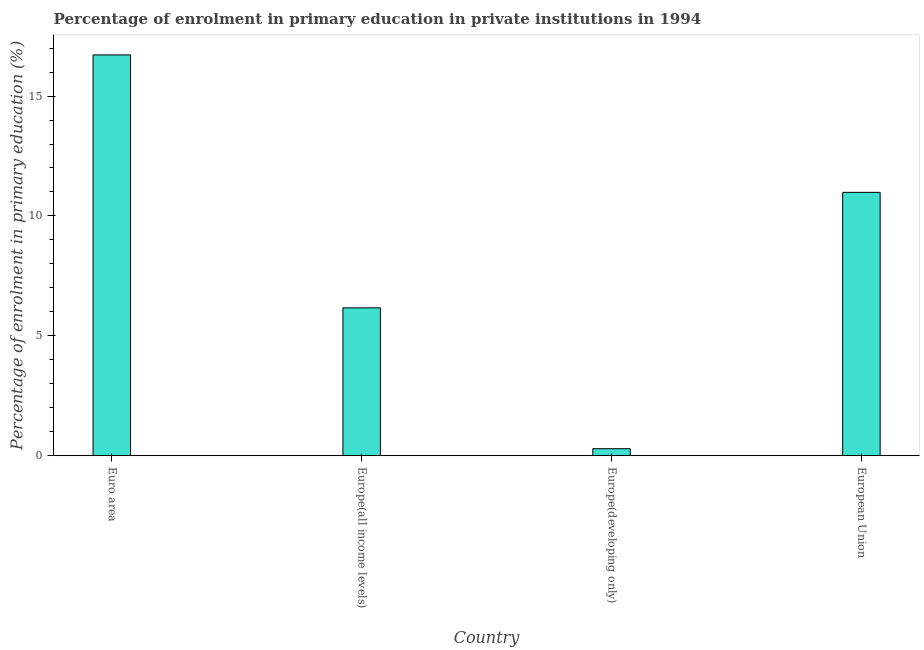Does the graph contain any zero values?
Give a very brief answer. No. Does the graph contain grids?
Offer a terse response. No. What is the title of the graph?
Keep it short and to the point. Percentage of enrolment in primary education in private institutions in 1994. What is the label or title of the X-axis?
Give a very brief answer. Country. What is the label or title of the Y-axis?
Your answer should be compact. Percentage of enrolment in primary education (%). What is the enrolment percentage in primary education in European Union?
Your answer should be compact. 10.98. Across all countries, what is the maximum enrolment percentage in primary education?
Offer a very short reply. 16.72. Across all countries, what is the minimum enrolment percentage in primary education?
Your response must be concise. 0.29. In which country was the enrolment percentage in primary education maximum?
Provide a short and direct response. Euro area. In which country was the enrolment percentage in primary education minimum?
Your answer should be very brief. Europe(developing only). What is the sum of the enrolment percentage in primary education?
Make the answer very short. 34.16. What is the difference between the enrolment percentage in primary education in Euro area and European Union?
Offer a terse response. 5.73. What is the average enrolment percentage in primary education per country?
Provide a short and direct response. 8.54. What is the median enrolment percentage in primary education?
Give a very brief answer. 8.58. What is the ratio of the enrolment percentage in primary education in Europe(all income levels) to that in Europe(developing only)?
Your answer should be very brief. 21.1. What is the difference between the highest and the second highest enrolment percentage in primary education?
Your response must be concise. 5.73. What is the difference between the highest and the lowest enrolment percentage in primary education?
Make the answer very short. 16.42. What is the Percentage of enrolment in primary education (%) in Euro area?
Offer a very short reply. 16.72. What is the Percentage of enrolment in primary education (%) in Europe(all income levels)?
Provide a short and direct response. 6.17. What is the Percentage of enrolment in primary education (%) of Europe(developing only)?
Your response must be concise. 0.29. What is the Percentage of enrolment in primary education (%) in European Union?
Offer a very short reply. 10.98. What is the difference between the Percentage of enrolment in primary education (%) in Euro area and Europe(all income levels)?
Ensure brevity in your answer.  10.55. What is the difference between the Percentage of enrolment in primary education (%) in Euro area and Europe(developing only)?
Give a very brief answer. 16.42. What is the difference between the Percentage of enrolment in primary education (%) in Euro area and European Union?
Provide a succinct answer. 5.73. What is the difference between the Percentage of enrolment in primary education (%) in Europe(all income levels) and Europe(developing only)?
Provide a succinct answer. 5.88. What is the difference between the Percentage of enrolment in primary education (%) in Europe(all income levels) and European Union?
Keep it short and to the point. -4.82. What is the difference between the Percentage of enrolment in primary education (%) in Europe(developing only) and European Union?
Offer a terse response. -10.69. What is the ratio of the Percentage of enrolment in primary education (%) in Euro area to that in Europe(all income levels)?
Offer a very short reply. 2.71. What is the ratio of the Percentage of enrolment in primary education (%) in Euro area to that in Europe(developing only)?
Your answer should be compact. 57.18. What is the ratio of the Percentage of enrolment in primary education (%) in Euro area to that in European Union?
Ensure brevity in your answer.  1.52. What is the ratio of the Percentage of enrolment in primary education (%) in Europe(all income levels) to that in Europe(developing only)?
Ensure brevity in your answer.  21.1. What is the ratio of the Percentage of enrolment in primary education (%) in Europe(all income levels) to that in European Union?
Offer a very short reply. 0.56. What is the ratio of the Percentage of enrolment in primary education (%) in Europe(developing only) to that in European Union?
Offer a very short reply. 0.03. 